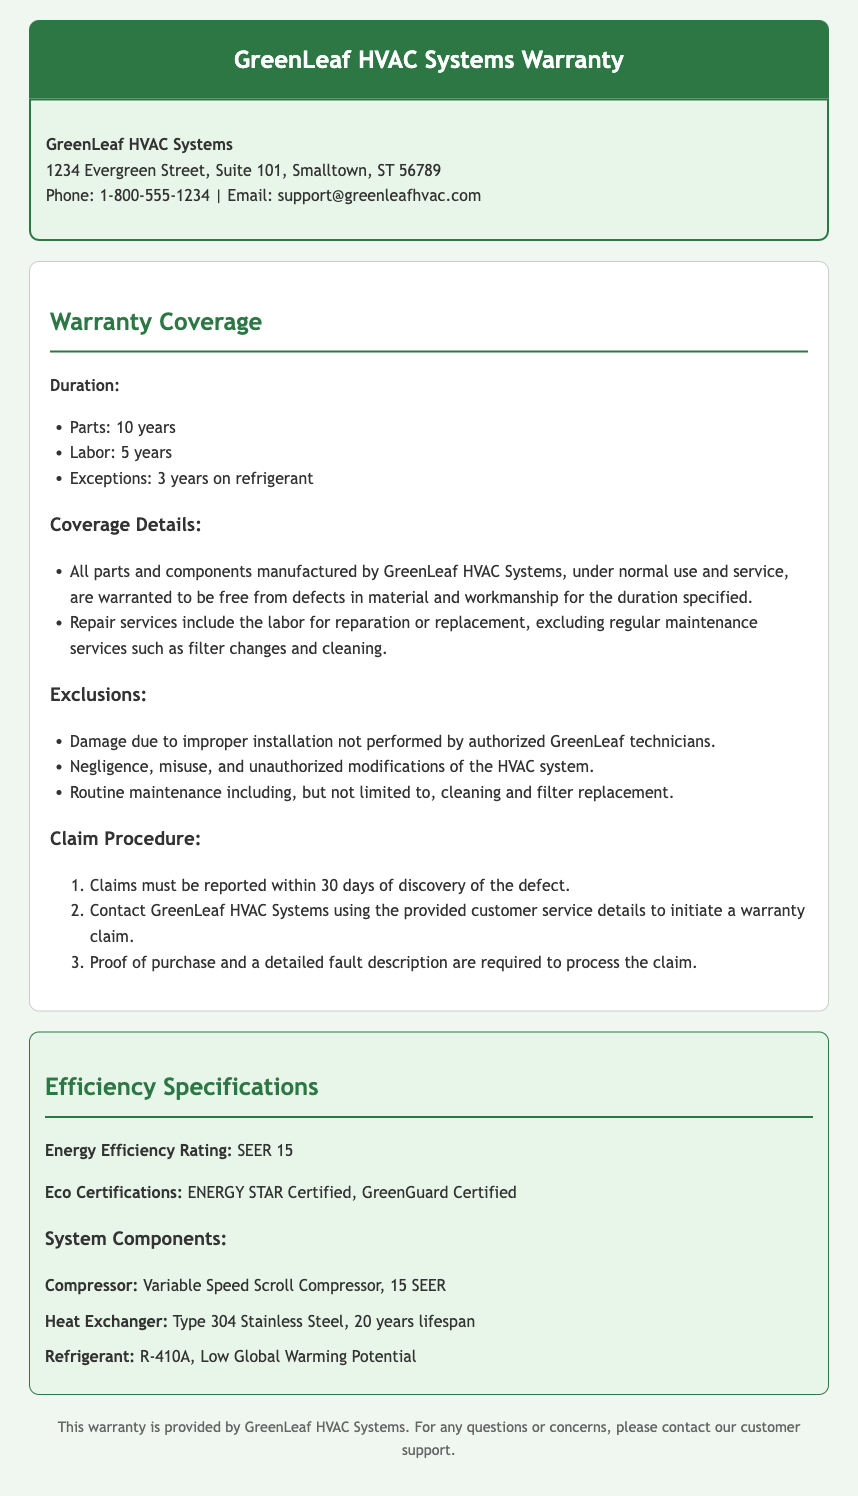What is the duration for parts warranty? The document specifies a parts warranty duration of 10 years.
Answer: 10 years What is the labor warranty duration? The labor warranty duration mentioned is 5 years.
Answer: 5 years What is excluded from the warranty coverage? One exclusion noted is negligence, misuse, and unauthorized modifications of the HVAC system.
Answer: Negligence What is the Energy Efficiency Rating of the system? The document states that the Energy Efficiency Rating is SEER 15.
Answer: SEER 15 What type of refrigerant is used? The refrigerant mentioned in the document is R-410A.
Answer: R-410A What must be reported within 30 days according to the claim procedure? Claims must be reported within 30 days of discovery of the defect.
Answer: Defect How long is the coverage for the heat exchanger? The heat exchanger has a specified lifespan of 20 years.
Answer: 20 years Which certification is mentioned for Energy efficiency? The document mentions ENERGY STAR Certified as one of the eco certifications.
Answer: ENERGY STAR Certified What is the warranty claim contact method? Contacting GreenLeaf HVAC Systems using the provided customer service details is required to initiate a claim.
Answer: Customer service details 